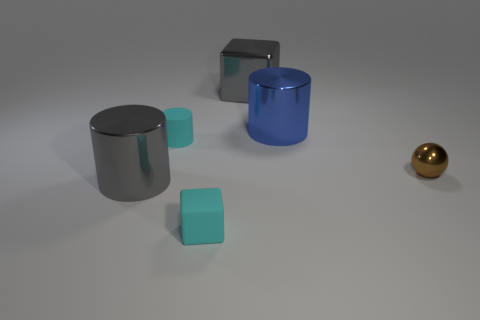How many metallic things are either large red balls or big gray cylinders?
Give a very brief answer. 1. There is a big metallic cylinder in front of the blue metal thing that is on the right side of the large block; how many tiny cyan cylinders are behind it?
Your answer should be compact. 1. There is a metallic cylinder that is behind the tiny brown shiny ball; does it have the same size as the cyan object that is to the left of the small cyan matte cube?
Provide a succinct answer. No. There is a big gray object that is the same shape as the large blue metal object; what material is it?
Offer a very short reply. Metal. How many small objects are either gray metallic blocks or yellow matte cubes?
Your response must be concise. 0. What is the material of the tiny cyan cube?
Your response must be concise. Rubber. There is a thing that is to the right of the matte cube and in front of the cyan cylinder; what is its material?
Ensure brevity in your answer.  Metal. Do the tiny rubber cylinder and the block on the left side of the gray shiny block have the same color?
Make the answer very short. Yes. There is a blue thing that is the same size as the gray metallic cylinder; what is its material?
Your answer should be compact. Metal. Is there a sphere that has the same material as the brown thing?
Offer a very short reply. No. 